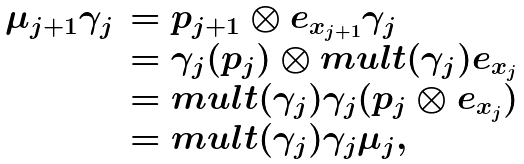Convert formula to latex. <formula><loc_0><loc_0><loc_500><loc_500>\begin{array} { r l } \mu _ { j + 1 } \gamma _ { j } & = p _ { j + 1 } \otimes e _ { x _ { j + 1 } } \gamma _ { j } \\ & = \gamma _ { j } ( p _ { j } ) \otimes m u l t ( \gamma _ { j } ) e _ { x _ { j } } \\ & = m u l t ( \gamma _ { j } ) \gamma _ { j } ( p _ { j } \otimes e _ { x _ { j } } ) \\ & = m u l t ( \gamma _ { j } ) \gamma _ { j } \mu _ { j } , \end{array}</formula> 